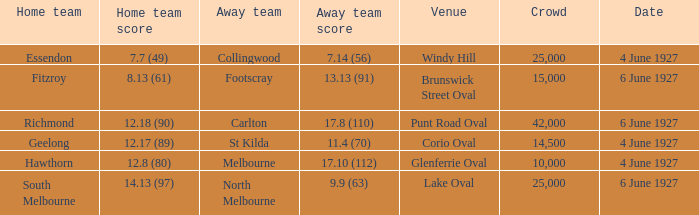How many people in the crowd with north melbourne as an away team? 25000.0. 